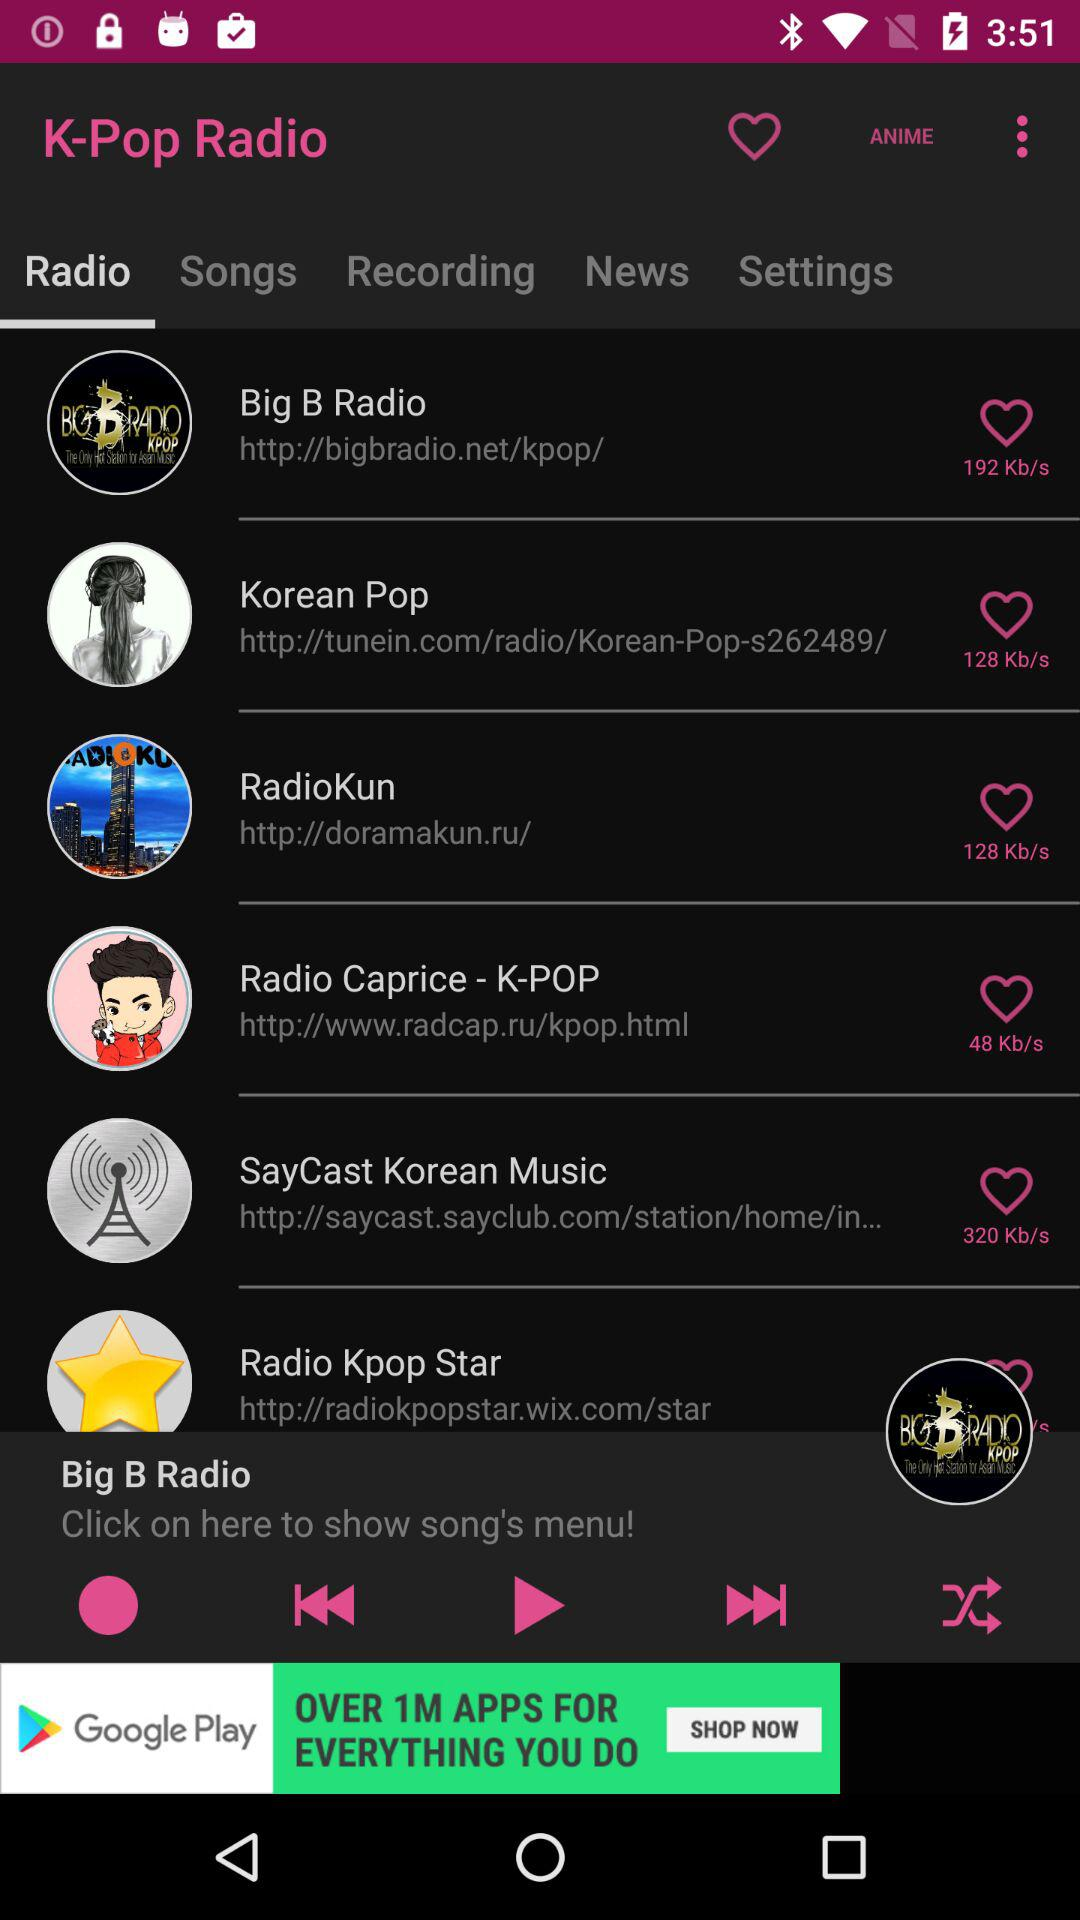Which option is selected in "K-Pop Radio"? The selected option is "Radio". 